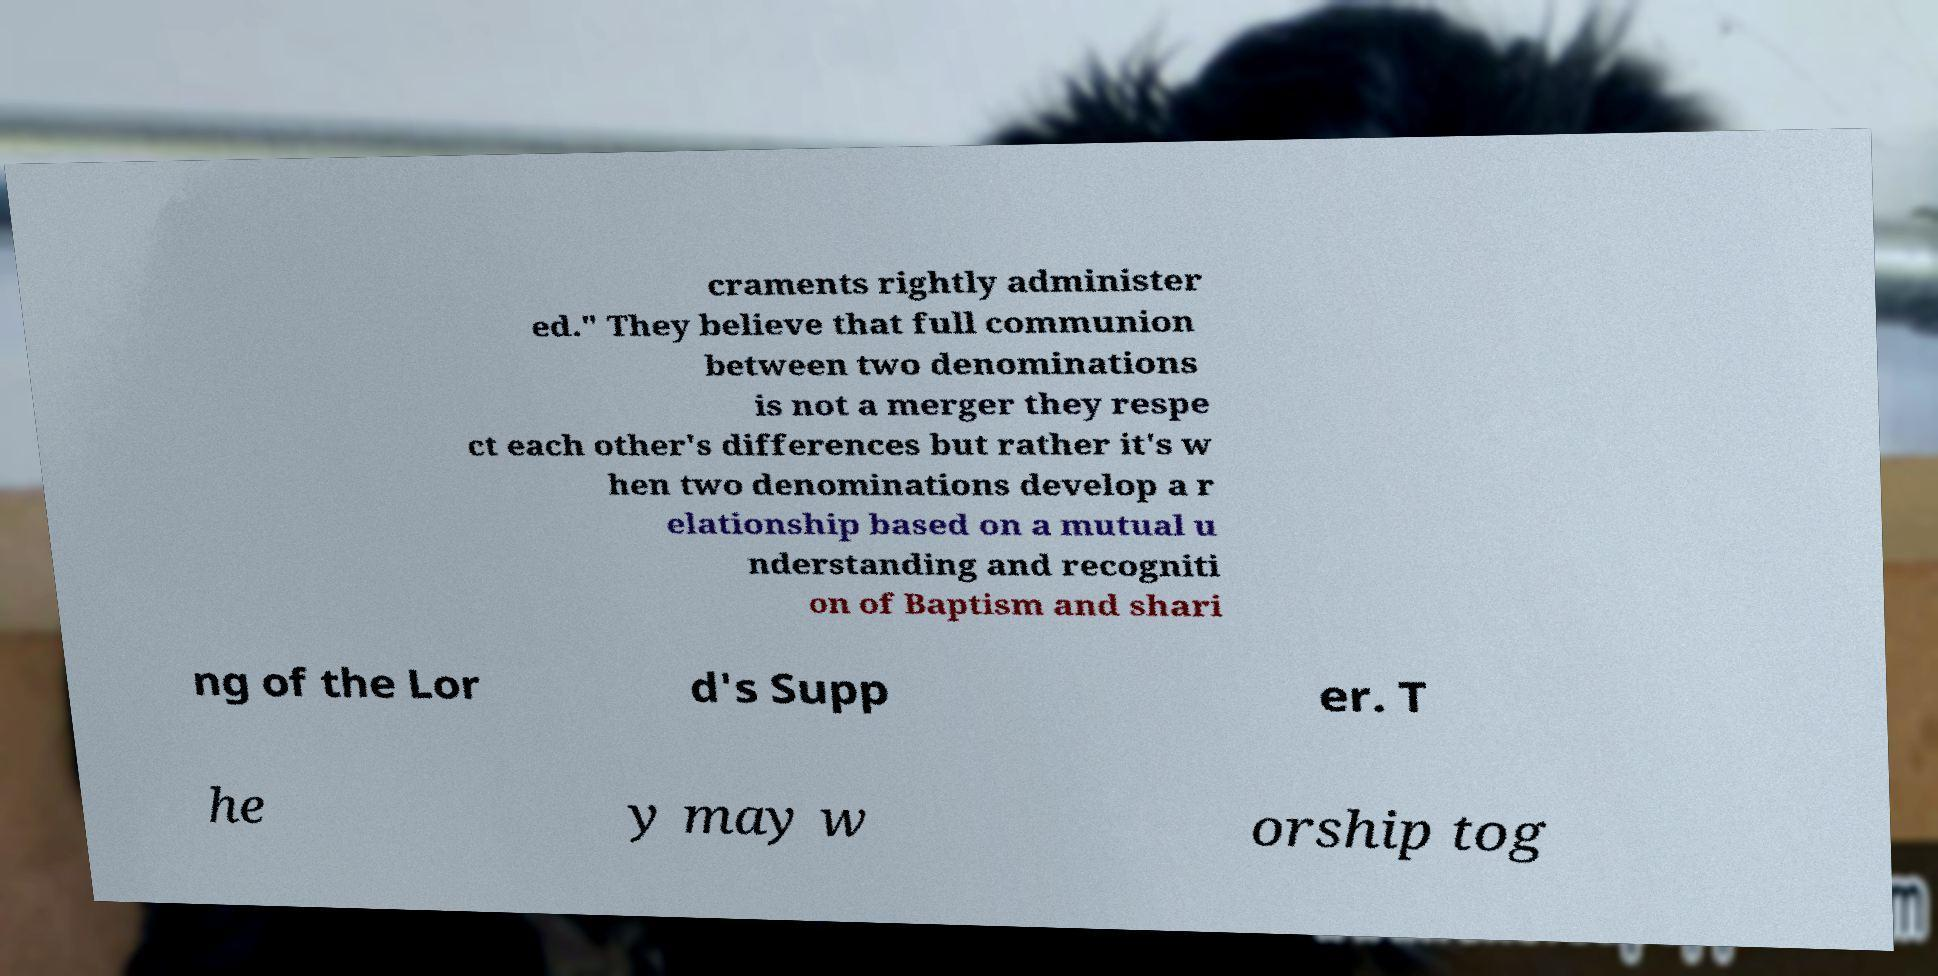For documentation purposes, I need the text within this image transcribed. Could you provide that? craments rightly administer ed." They believe that full communion between two denominations is not a merger they respe ct each other's differences but rather it's w hen two denominations develop a r elationship based on a mutual u nderstanding and recogniti on of Baptism and shari ng of the Lor d's Supp er. T he y may w orship tog 